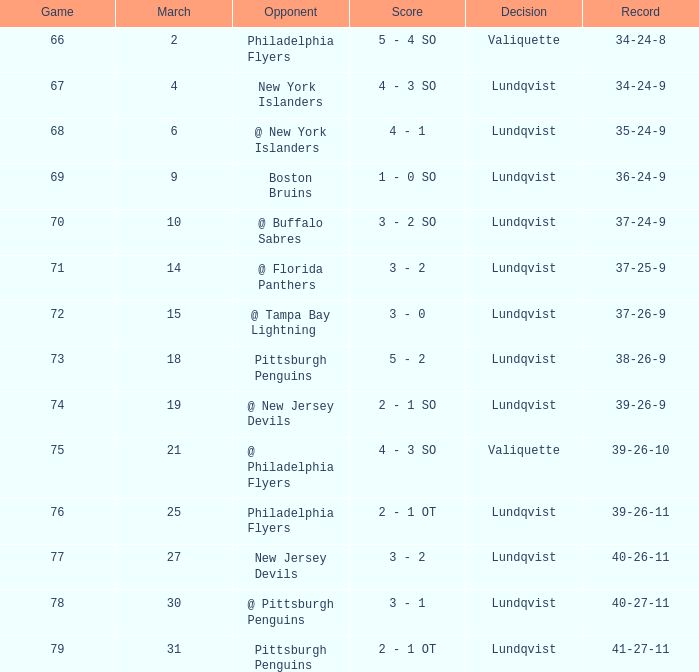Which competitor's march was 31? Pittsburgh Penguins. 